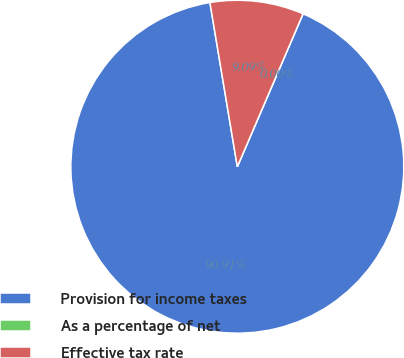Convert chart to OTSL. <chart><loc_0><loc_0><loc_500><loc_500><pie_chart><fcel>Provision for income taxes<fcel>As a percentage of net<fcel>Effective tax rate<nl><fcel>90.91%<fcel>0.0%<fcel>9.09%<nl></chart> 